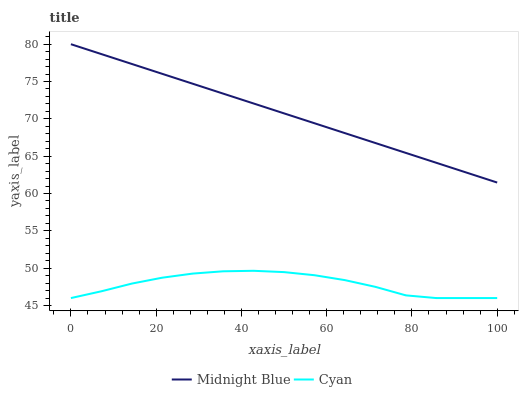Does Cyan have the minimum area under the curve?
Answer yes or no. Yes. Does Midnight Blue have the maximum area under the curve?
Answer yes or no. Yes. Does Midnight Blue have the minimum area under the curve?
Answer yes or no. No. Is Midnight Blue the smoothest?
Answer yes or no. Yes. Is Cyan the roughest?
Answer yes or no. Yes. Is Midnight Blue the roughest?
Answer yes or no. No. Does Cyan have the lowest value?
Answer yes or no. Yes. Does Midnight Blue have the lowest value?
Answer yes or no. No. Does Midnight Blue have the highest value?
Answer yes or no. Yes. Is Cyan less than Midnight Blue?
Answer yes or no. Yes. Is Midnight Blue greater than Cyan?
Answer yes or no. Yes. Does Cyan intersect Midnight Blue?
Answer yes or no. No. 